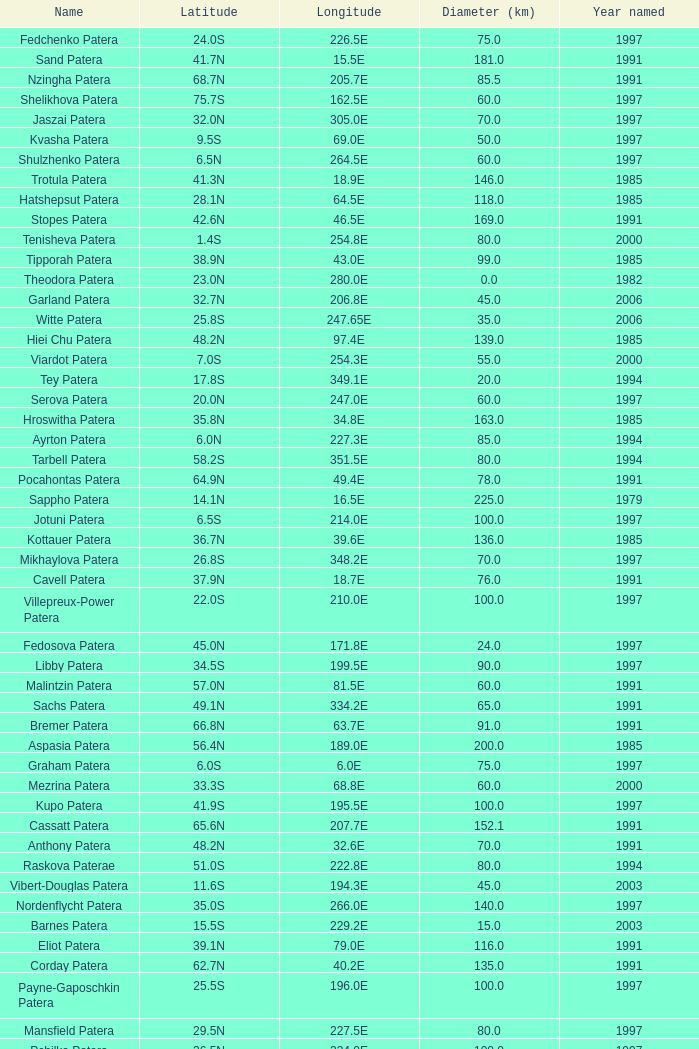What is Longitude, when Name is Raskova Paterae? 222.8E. 